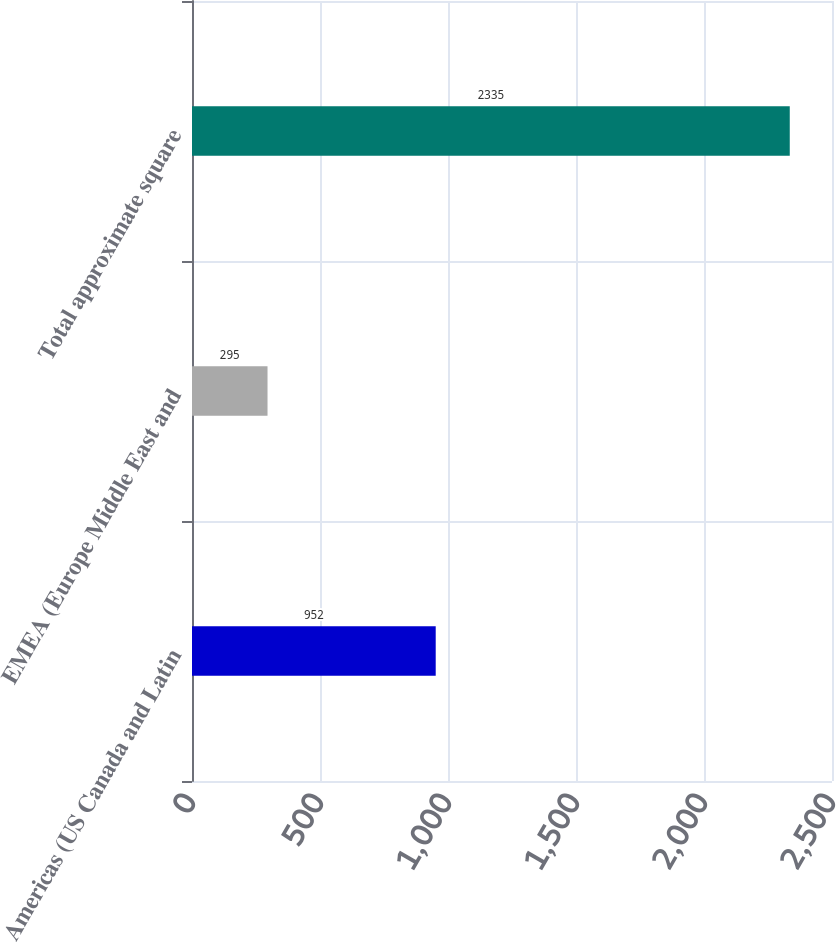<chart> <loc_0><loc_0><loc_500><loc_500><bar_chart><fcel>Americas (US Canada and Latin<fcel>EMEA (Europe Middle East and<fcel>Total approximate square<nl><fcel>952<fcel>295<fcel>2335<nl></chart> 